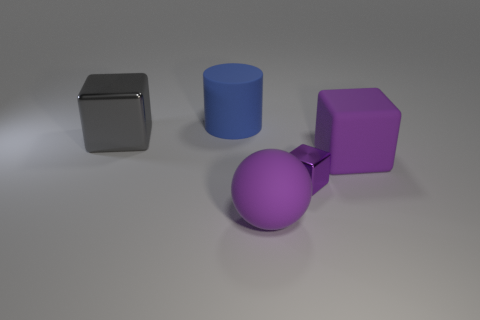Add 3 cyan things. How many objects exist? 8 Subtract all purple blocks. How many blocks are left? 1 Add 1 big gray things. How many big gray things are left? 2 Add 1 big purple rubber blocks. How many big purple rubber blocks exist? 2 Subtract all gray cubes. How many cubes are left? 2 Subtract 0 yellow cylinders. How many objects are left? 5 Subtract all spheres. How many objects are left? 4 Subtract 1 cylinders. How many cylinders are left? 0 Subtract all cyan cylinders. Subtract all brown balls. How many cylinders are left? 1 Subtract all yellow balls. How many red cylinders are left? 0 